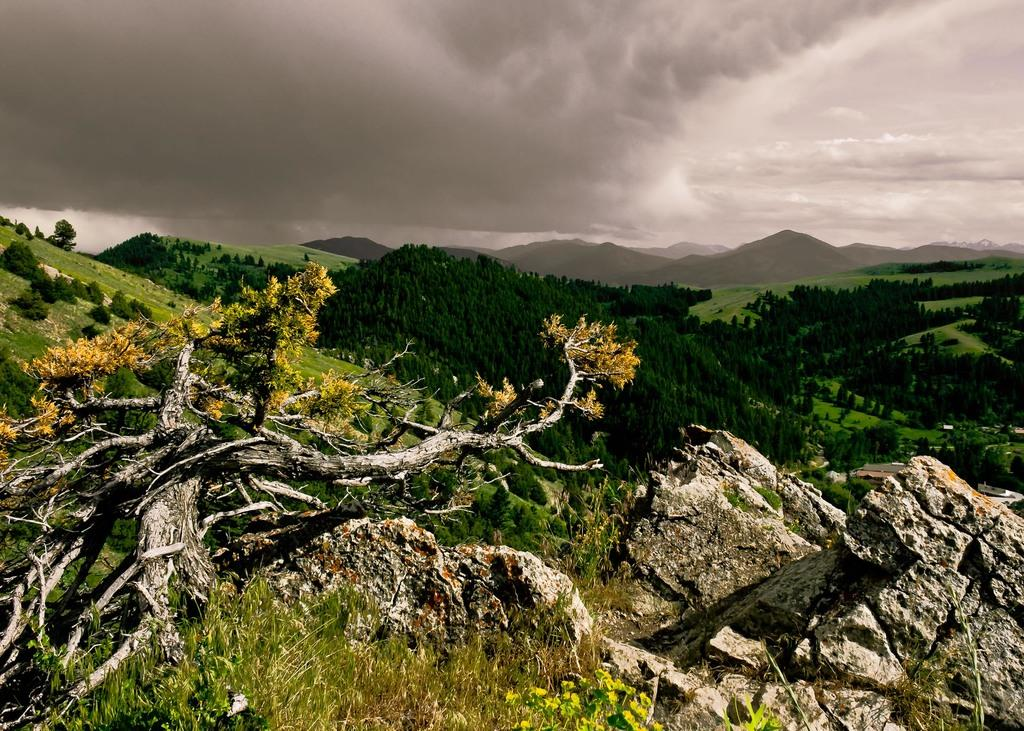What type of vegetation can be seen in the image? There are plants and trees in the image. What geological features are present in the image? There are rocks and mountains in the image. What is visible in the background of the image? The sky is visible in the background of the image. What atmospheric conditions can be observed in the sky? Clouds are present in the sky. What type of grape is being used to slow down the car in the image? There is no car or grape present in the image; it features plants, rocks, trees, mountains, and a sky with clouds. How does the friction between the rocks and the trees affect the movement of the clouds in the image? The image does not depict any interaction between the rocks, trees, and clouds that would result in friction affecting their movement. 